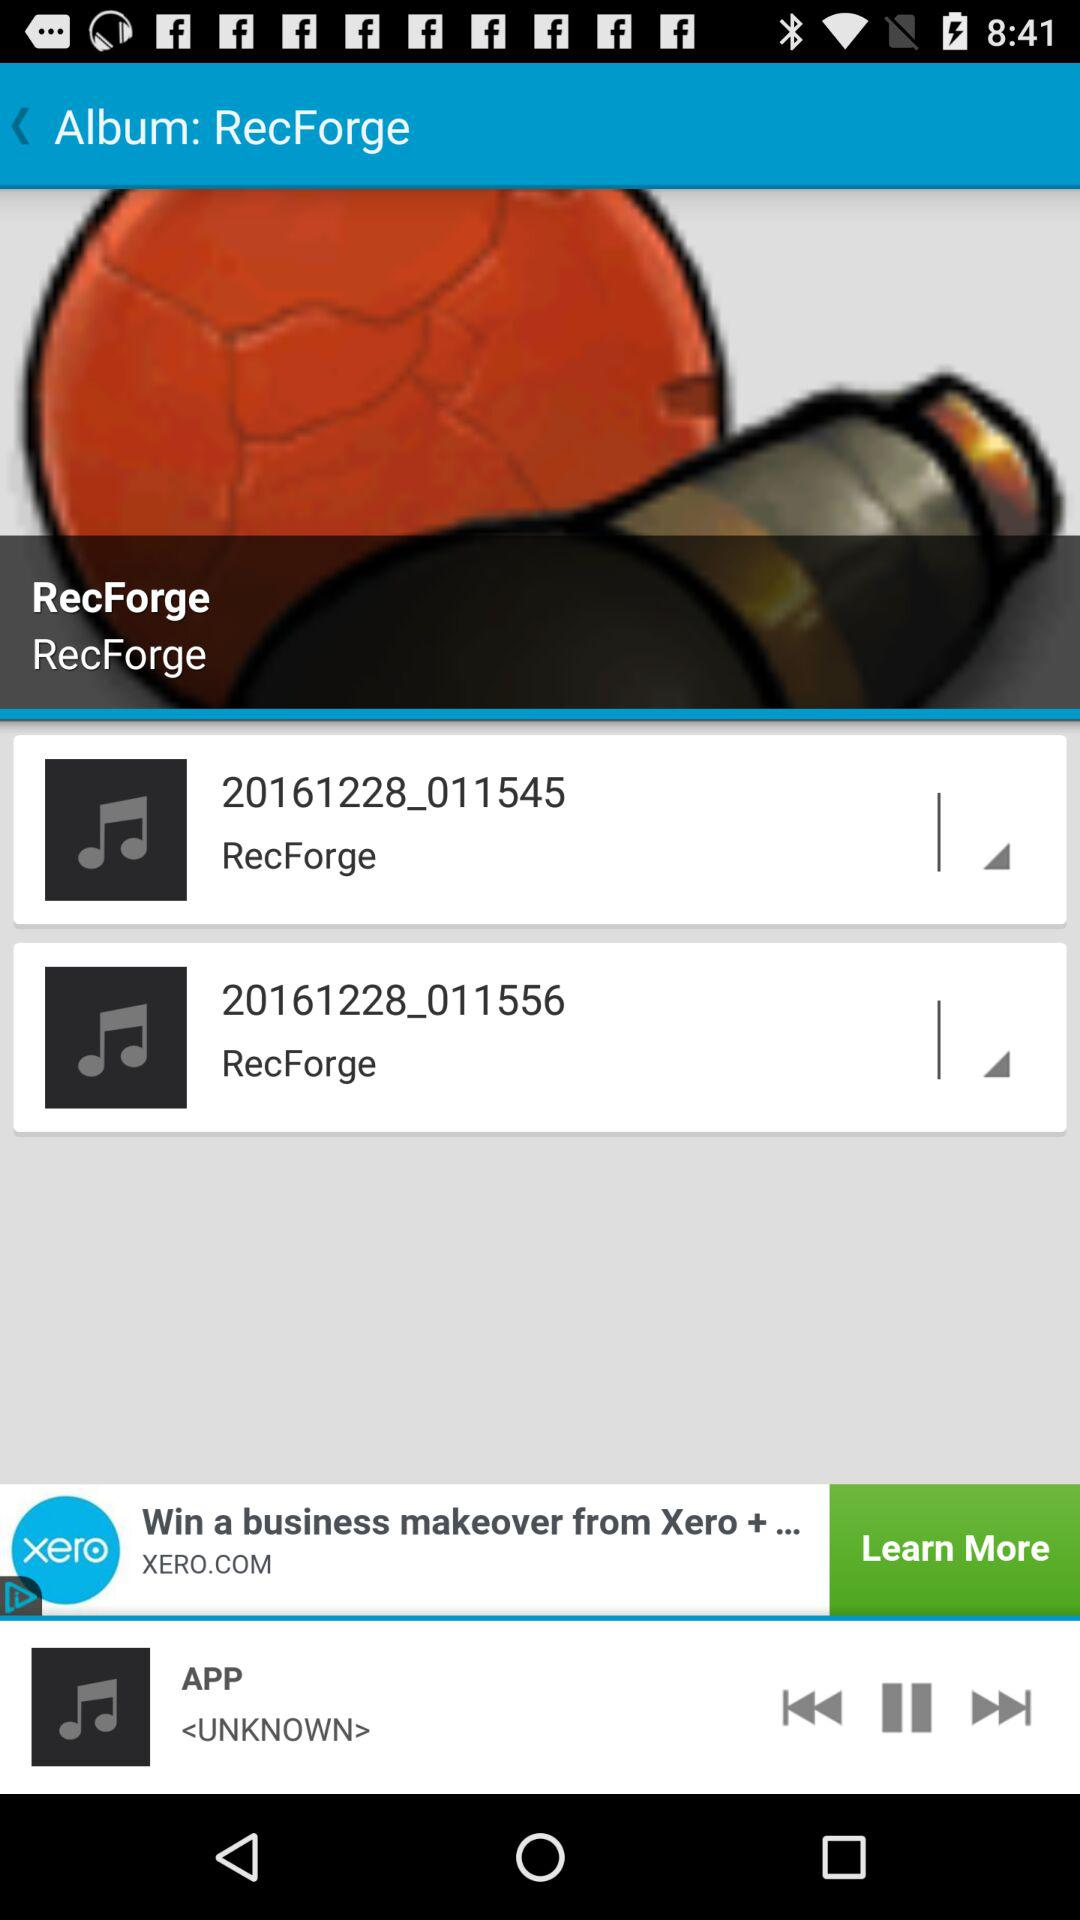Which audio is playing? The audio that is playing is "APP". 